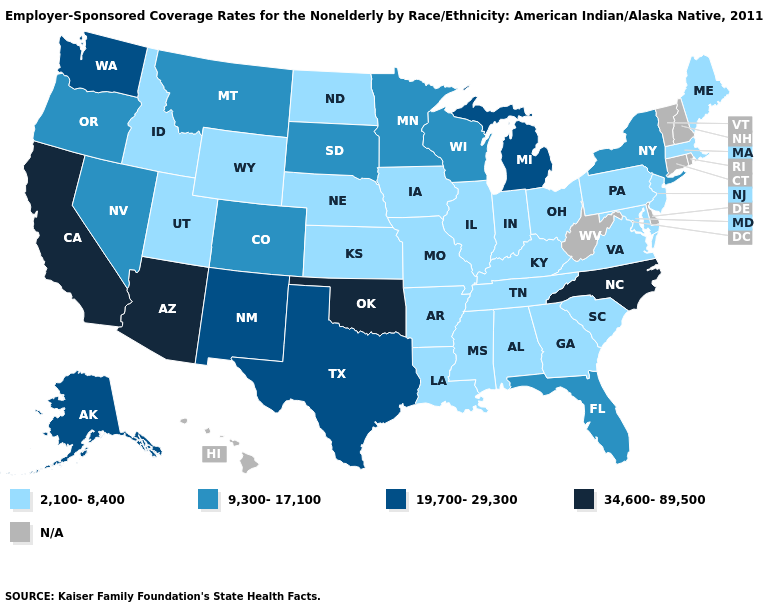Does the map have missing data?
Concise answer only. Yes. What is the highest value in the West ?
Quick response, please. 34,600-89,500. What is the value of Massachusetts?
Keep it brief. 2,100-8,400. Name the states that have a value in the range 19,700-29,300?
Keep it brief. Alaska, Michigan, New Mexico, Texas, Washington. What is the value of Kentucky?
Give a very brief answer. 2,100-8,400. What is the value of Nebraska?
Keep it brief. 2,100-8,400. Which states have the highest value in the USA?
Write a very short answer. Arizona, California, North Carolina, Oklahoma. What is the value of Oregon?
Answer briefly. 9,300-17,100. What is the lowest value in the USA?
Answer briefly. 2,100-8,400. What is the highest value in states that border North Carolina?
Short answer required. 2,100-8,400. Name the states that have a value in the range 19,700-29,300?
Keep it brief. Alaska, Michigan, New Mexico, Texas, Washington. Name the states that have a value in the range 34,600-89,500?
Quick response, please. Arizona, California, North Carolina, Oklahoma. Among the states that border Florida , which have the highest value?
Keep it brief. Alabama, Georgia. 